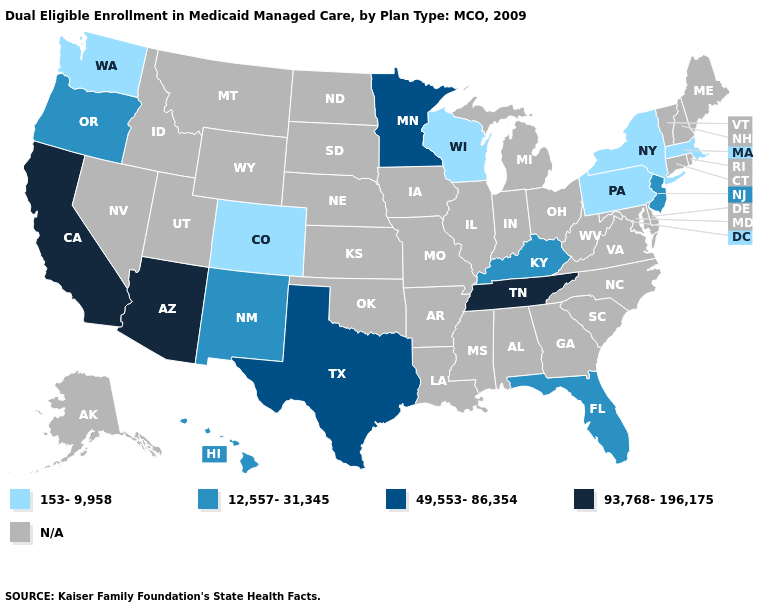Does Wisconsin have the lowest value in the MidWest?
Answer briefly. Yes. Which states have the lowest value in the West?
Be succinct. Colorado, Washington. Among the states that border Oregon , which have the lowest value?
Write a very short answer. Washington. What is the value of New York?
Keep it brief. 153-9,958. Among the states that border Pennsylvania , does New York have the highest value?
Give a very brief answer. No. Name the states that have a value in the range 12,557-31,345?
Keep it brief. Florida, Hawaii, Kentucky, New Jersey, New Mexico, Oregon. Does Arizona have the lowest value in the West?
Be succinct. No. Among the states that border Wyoming , which have the lowest value?
Short answer required. Colorado. Does Tennessee have the lowest value in the USA?
Answer briefly. No. Which states have the highest value in the USA?
Answer briefly. Arizona, California, Tennessee. What is the highest value in the Northeast ?
Write a very short answer. 12,557-31,345. What is the lowest value in states that border Illinois?
Quick response, please. 153-9,958. Which states hav the highest value in the Northeast?
Short answer required. New Jersey. Name the states that have a value in the range 153-9,958?
Short answer required. Colorado, Massachusetts, New York, Pennsylvania, Washington, Wisconsin. 